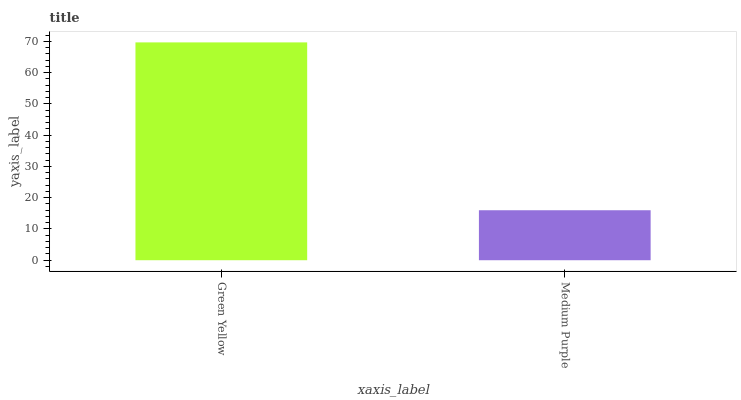Is Medium Purple the minimum?
Answer yes or no. Yes. Is Green Yellow the maximum?
Answer yes or no. Yes. Is Medium Purple the maximum?
Answer yes or no. No. Is Green Yellow greater than Medium Purple?
Answer yes or no. Yes. Is Medium Purple less than Green Yellow?
Answer yes or no. Yes. Is Medium Purple greater than Green Yellow?
Answer yes or no. No. Is Green Yellow less than Medium Purple?
Answer yes or no. No. Is Green Yellow the high median?
Answer yes or no. Yes. Is Medium Purple the low median?
Answer yes or no. Yes. Is Medium Purple the high median?
Answer yes or no. No. Is Green Yellow the low median?
Answer yes or no. No. 